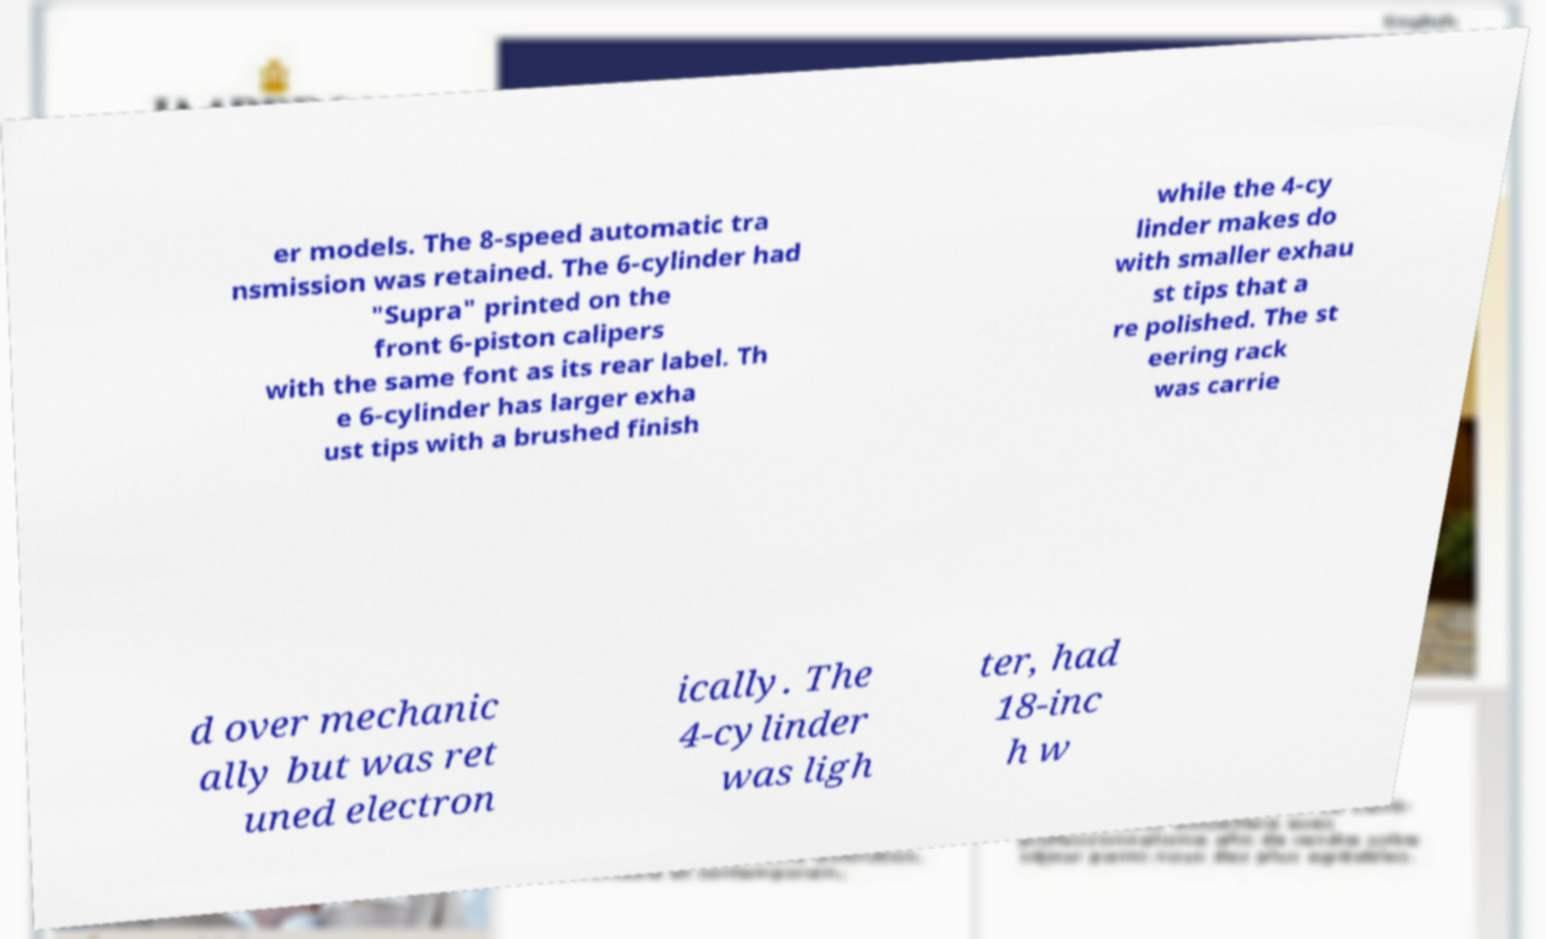Could you assist in decoding the text presented in this image and type it out clearly? er models. The 8-speed automatic tra nsmission was retained. The 6-cylinder had "Supra" printed on the front 6-piston calipers with the same font as its rear label. Th e 6-cylinder has larger exha ust tips with a brushed finish while the 4-cy linder makes do with smaller exhau st tips that a re polished. The st eering rack was carrie d over mechanic ally but was ret uned electron ically. The 4-cylinder was ligh ter, had 18-inc h w 